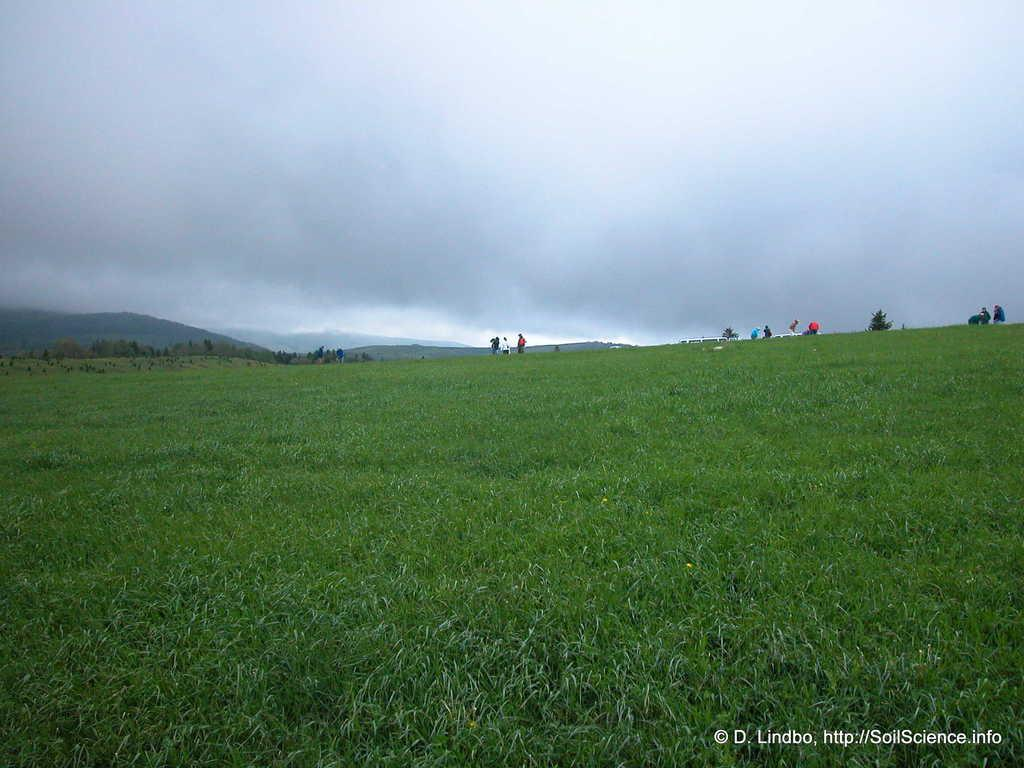What type of vegetation is at the bottom of the image? There is grass at the bottom of the image. What is visible at the top of the image? The sky is visible at the top of the image. What is the weather like in the image? The sky is cloudy, which suggests a partly cloudy or overcast condition. How many oranges are hanging from the clouds in the image? There are no oranges present in the image; it features grass and a cloudy sky. Can you describe the relationship between the grass and the friend in the image? There is no friend present in the image, as it only features grass and a cloudy sky. 